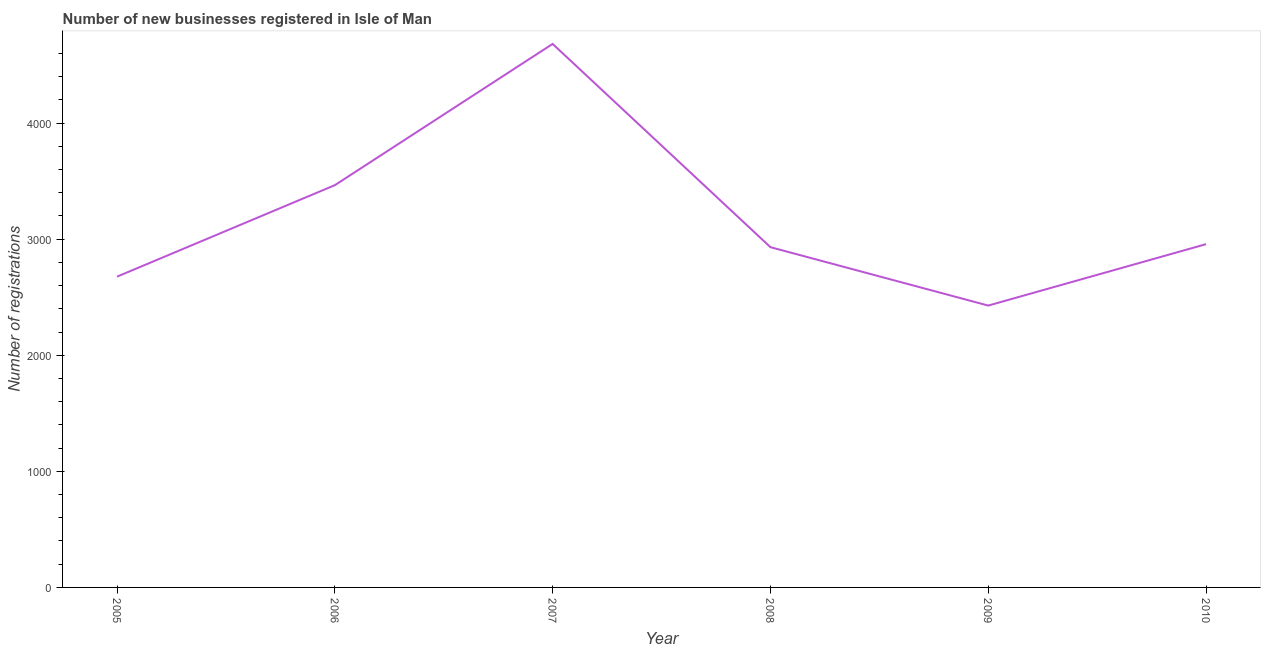What is the number of new business registrations in 2010?
Ensure brevity in your answer.  2957. Across all years, what is the maximum number of new business registrations?
Provide a short and direct response. 4682. Across all years, what is the minimum number of new business registrations?
Offer a terse response. 2428. In which year was the number of new business registrations minimum?
Your response must be concise. 2009. What is the sum of the number of new business registrations?
Ensure brevity in your answer.  1.91e+04. What is the difference between the number of new business registrations in 2008 and 2009?
Give a very brief answer. 503. What is the average number of new business registrations per year?
Provide a short and direct response. 3190. What is the median number of new business registrations?
Ensure brevity in your answer.  2944. In how many years, is the number of new business registrations greater than 2400 ?
Offer a very short reply. 6. Do a majority of the years between 2009 and 2006 (inclusive) have number of new business registrations greater than 800 ?
Make the answer very short. Yes. What is the ratio of the number of new business registrations in 2005 to that in 2006?
Ensure brevity in your answer.  0.77. Is the difference between the number of new business registrations in 2007 and 2010 greater than the difference between any two years?
Your answer should be compact. No. What is the difference between the highest and the second highest number of new business registrations?
Your answer should be compact. 1217. Is the sum of the number of new business registrations in 2009 and 2010 greater than the maximum number of new business registrations across all years?
Your answer should be compact. Yes. What is the difference between the highest and the lowest number of new business registrations?
Keep it short and to the point. 2254. Does the number of new business registrations monotonically increase over the years?
Your answer should be very brief. No. How many lines are there?
Provide a succinct answer. 1. What is the difference between two consecutive major ticks on the Y-axis?
Provide a succinct answer. 1000. Are the values on the major ticks of Y-axis written in scientific E-notation?
Your answer should be very brief. No. Does the graph contain grids?
Your answer should be very brief. No. What is the title of the graph?
Keep it short and to the point. Number of new businesses registered in Isle of Man. What is the label or title of the X-axis?
Make the answer very short. Year. What is the label or title of the Y-axis?
Offer a terse response. Number of registrations. What is the Number of registrations of 2005?
Give a very brief answer. 2677. What is the Number of registrations of 2006?
Make the answer very short. 3465. What is the Number of registrations of 2007?
Make the answer very short. 4682. What is the Number of registrations in 2008?
Offer a very short reply. 2931. What is the Number of registrations of 2009?
Keep it short and to the point. 2428. What is the Number of registrations in 2010?
Offer a terse response. 2957. What is the difference between the Number of registrations in 2005 and 2006?
Give a very brief answer. -788. What is the difference between the Number of registrations in 2005 and 2007?
Offer a terse response. -2005. What is the difference between the Number of registrations in 2005 and 2008?
Give a very brief answer. -254. What is the difference between the Number of registrations in 2005 and 2009?
Ensure brevity in your answer.  249. What is the difference between the Number of registrations in 2005 and 2010?
Give a very brief answer. -280. What is the difference between the Number of registrations in 2006 and 2007?
Offer a very short reply. -1217. What is the difference between the Number of registrations in 2006 and 2008?
Ensure brevity in your answer.  534. What is the difference between the Number of registrations in 2006 and 2009?
Provide a succinct answer. 1037. What is the difference between the Number of registrations in 2006 and 2010?
Make the answer very short. 508. What is the difference between the Number of registrations in 2007 and 2008?
Offer a terse response. 1751. What is the difference between the Number of registrations in 2007 and 2009?
Offer a very short reply. 2254. What is the difference between the Number of registrations in 2007 and 2010?
Ensure brevity in your answer.  1725. What is the difference between the Number of registrations in 2008 and 2009?
Offer a very short reply. 503. What is the difference between the Number of registrations in 2008 and 2010?
Offer a very short reply. -26. What is the difference between the Number of registrations in 2009 and 2010?
Your response must be concise. -529. What is the ratio of the Number of registrations in 2005 to that in 2006?
Provide a short and direct response. 0.77. What is the ratio of the Number of registrations in 2005 to that in 2007?
Provide a succinct answer. 0.57. What is the ratio of the Number of registrations in 2005 to that in 2009?
Keep it short and to the point. 1.1. What is the ratio of the Number of registrations in 2005 to that in 2010?
Keep it short and to the point. 0.91. What is the ratio of the Number of registrations in 2006 to that in 2007?
Ensure brevity in your answer.  0.74. What is the ratio of the Number of registrations in 2006 to that in 2008?
Your answer should be compact. 1.18. What is the ratio of the Number of registrations in 2006 to that in 2009?
Ensure brevity in your answer.  1.43. What is the ratio of the Number of registrations in 2006 to that in 2010?
Offer a terse response. 1.17. What is the ratio of the Number of registrations in 2007 to that in 2008?
Offer a very short reply. 1.6. What is the ratio of the Number of registrations in 2007 to that in 2009?
Offer a very short reply. 1.93. What is the ratio of the Number of registrations in 2007 to that in 2010?
Provide a succinct answer. 1.58. What is the ratio of the Number of registrations in 2008 to that in 2009?
Give a very brief answer. 1.21. What is the ratio of the Number of registrations in 2009 to that in 2010?
Your answer should be very brief. 0.82. 